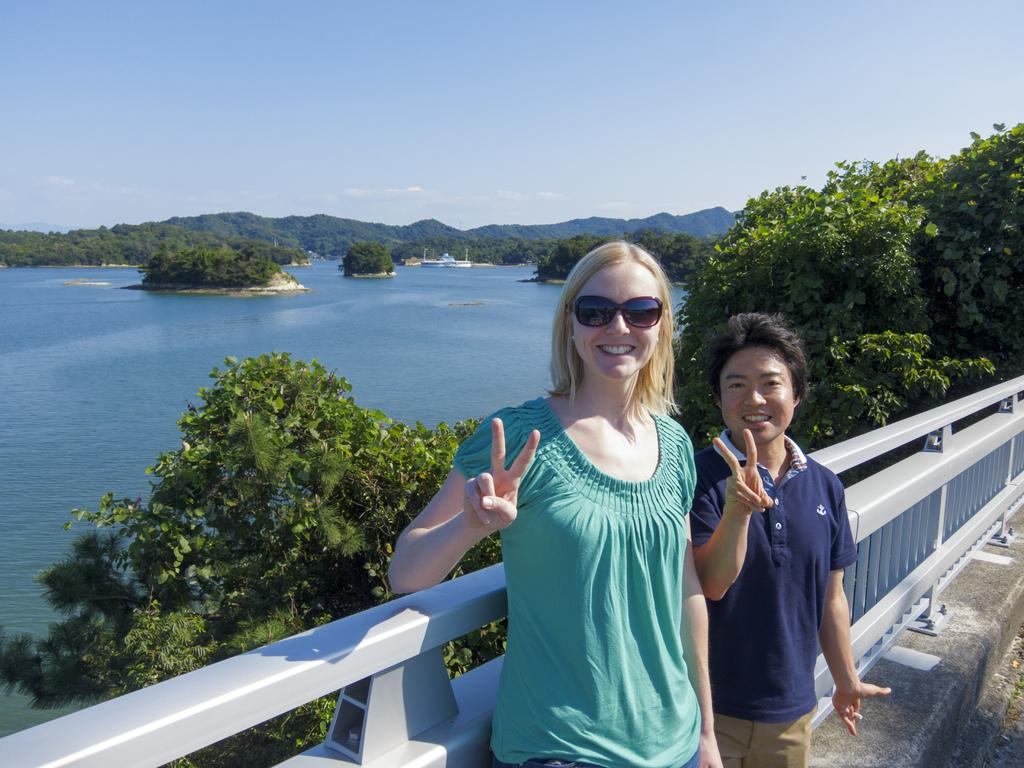How many people are in the image? There are two people in the image. What are the people doing in the image? The people are standing at the fence and smiling. What are the people wearing on their faces? The people are wearing goggles. What type of natural environment can be seen in the image? There are trees, water, mountains, and the sky visible in the image. What type of brain can be seen in the image? There is no brain visible in the image. Can you locate a map in the image? There is no map present in the image. 